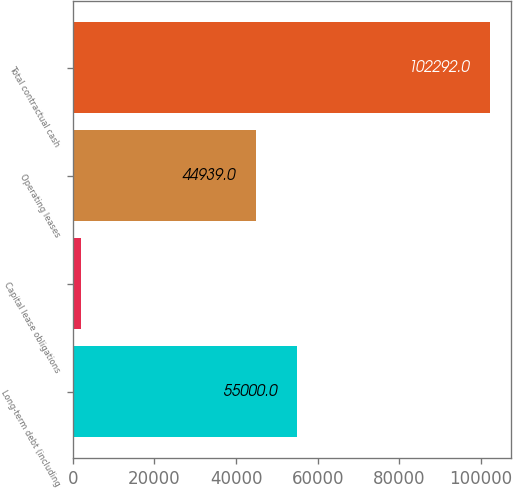Convert chart. <chart><loc_0><loc_0><loc_500><loc_500><bar_chart><fcel>Long-term debt (including<fcel>Capital lease obligations<fcel>Operating leases<fcel>Total contractual cash<nl><fcel>55000<fcel>2007<fcel>44939<fcel>102292<nl></chart> 